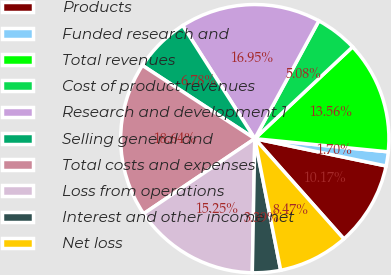<chart> <loc_0><loc_0><loc_500><loc_500><pie_chart><fcel>Products<fcel>Funded research and<fcel>Total revenues<fcel>Cost of product revenues<fcel>Research and development 1<fcel>Selling general and<fcel>Total costs and expenses<fcel>Loss from operations<fcel>Interest and other income net<fcel>Net loss<nl><fcel>10.17%<fcel>1.7%<fcel>13.56%<fcel>5.08%<fcel>16.95%<fcel>6.78%<fcel>18.64%<fcel>15.25%<fcel>3.39%<fcel>8.47%<nl></chart> 